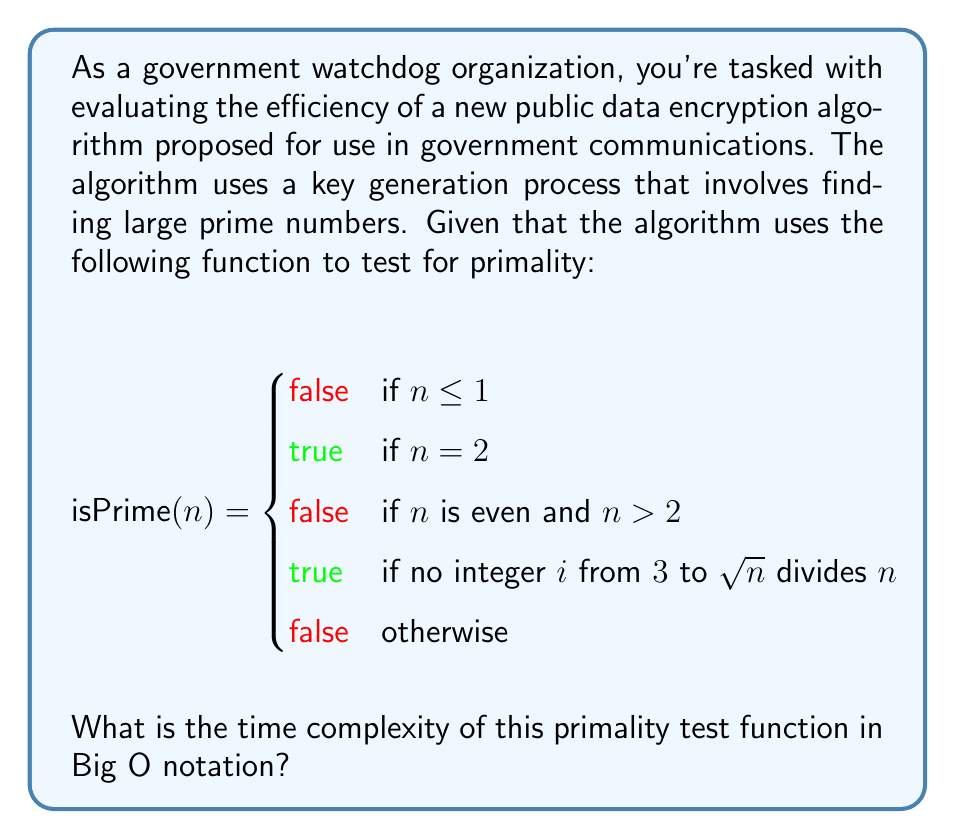Can you answer this question? To determine the time complexity of the isPrime function, we need to analyze its worst-case scenario:

1. The first three conditions (n ≤ 1, n = 2, n is even and > 2) are constant time operations: O(1)

2. The main computational work occurs in the fourth condition, where we check if any odd number from 3 to √n divides n.

3. This loop runs from 3 to √n, incrementing by 2 each time (to check only odd numbers).

4. The number of iterations in this loop is approximately:
   $$\frac{\sqrt{n} - 3}{2} + 1 \approx \frac{\sqrt{n}}{2}$$

5. Each iteration performs a division operation, which has a time complexity of O(log n) for large numbers.

6. Therefore, the total time complexity of the loop is:
   $$O(\frac{\sqrt{n}}{2} \cdot \log n) = O(\sqrt{n} \log n)$$

7. This dominates the constant time operations, so it represents the overall time complexity of the function.

Thus, the time complexity of the isPrime function is O(√n log n).
Answer: O(√n log n) 